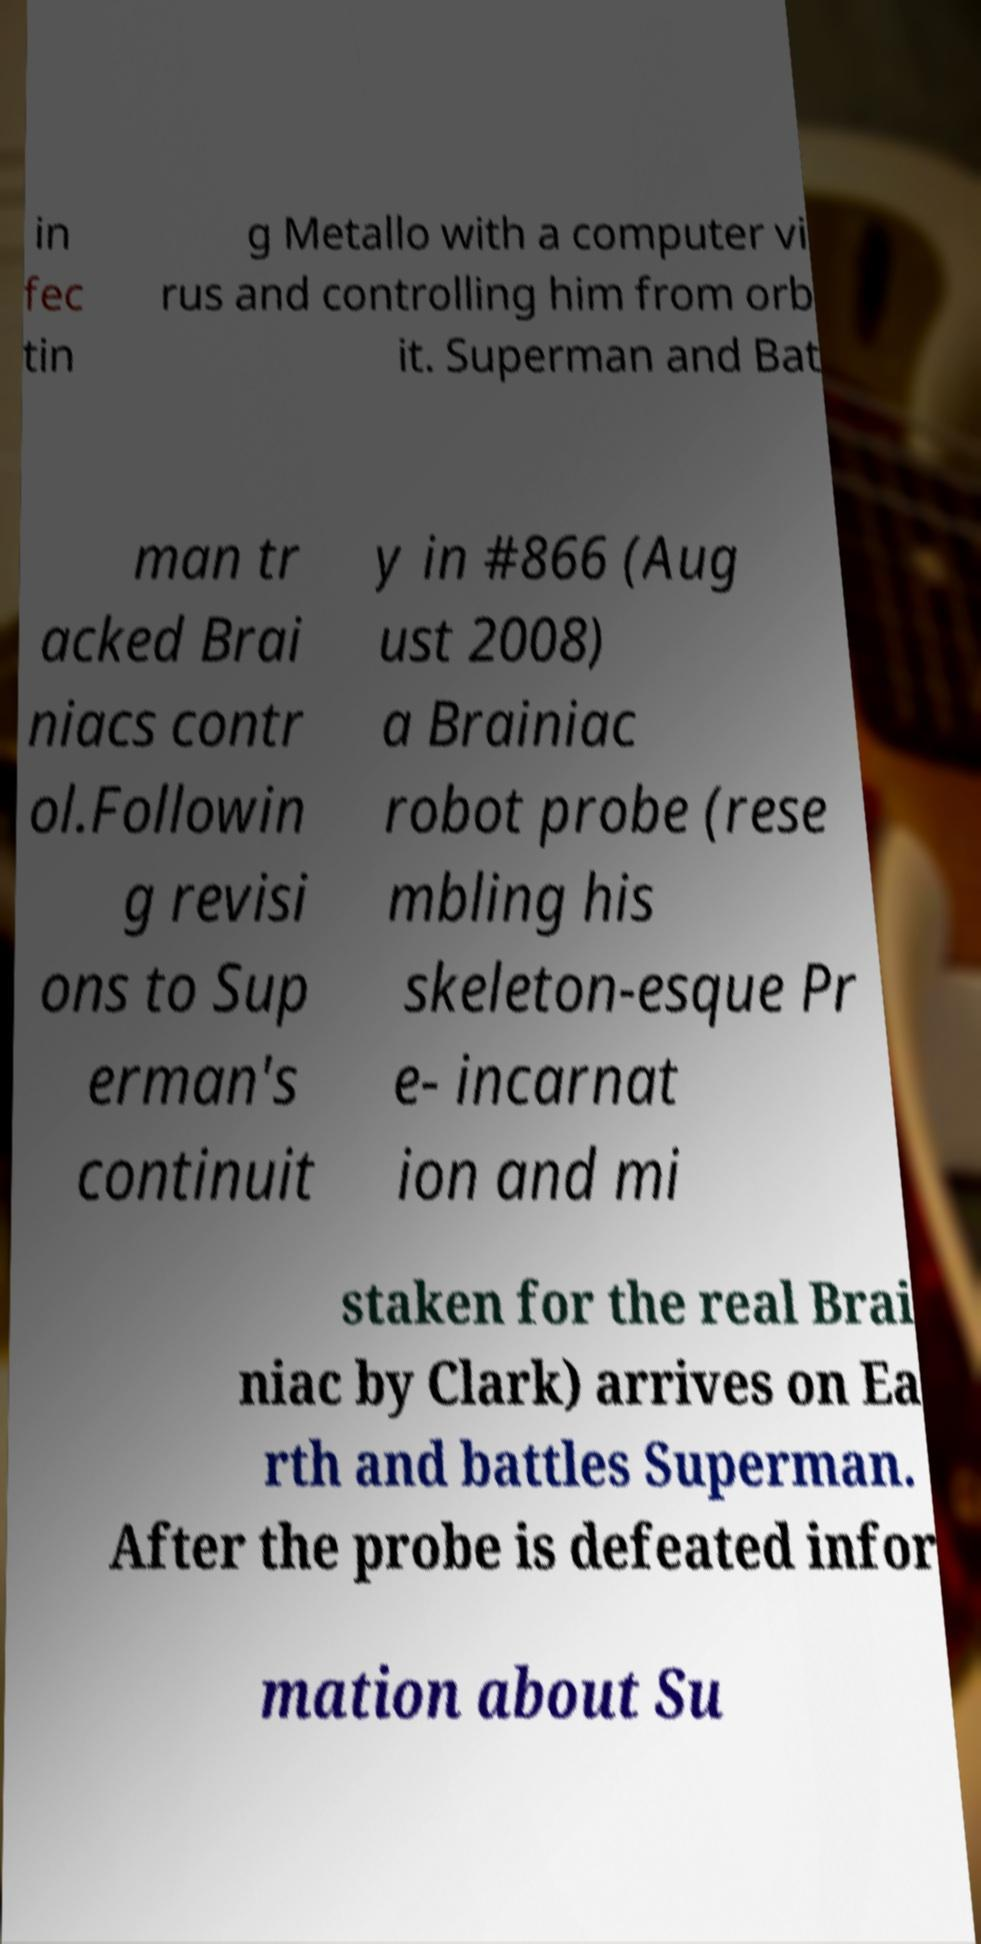What messages or text are displayed in this image? I need them in a readable, typed format. in fec tin g Metallo with a computer vi rus and controlling him from orb it. Superman and Bat man tr acked Brai niacs contr ol.Followin g revisi ons to Sup erman's continuit y in #866 (Aug ust 2008) a Brainiac robot probe (rese mbling his skeleton-esque Pr e- incarnat ion and mi staken for the real Brai niac by Clark) arrives on Ea rth and battles Superman. After the probe is defeated infor mation about Su 